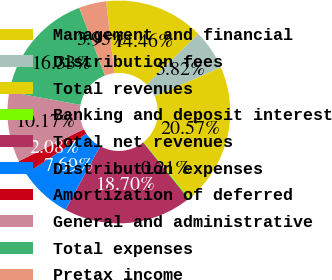Convert chart to OTSL. <chart><loc_0><loc_0><loc_500><loc_500><pie_chart><fcel>Management and financial<fcel>Distribution fees<fcel>Total revenues<fcel>Banking and deposit interest<fcel>Total net revenues<fcel>Distribution expenses<fcel>Amortization of deferred<fcel>General and administrative<fcel>Total expenses<fcel>Pretax income<nl><fcel>14.46%<fcel>5.82%<fcel>20.57%<fcel>0.21%<fcel>18.7%<fcel>7.69%<fcel>2.08%<fcel>10.17%<fcel>16.33%<fcel>3.95%<nl></chart> 